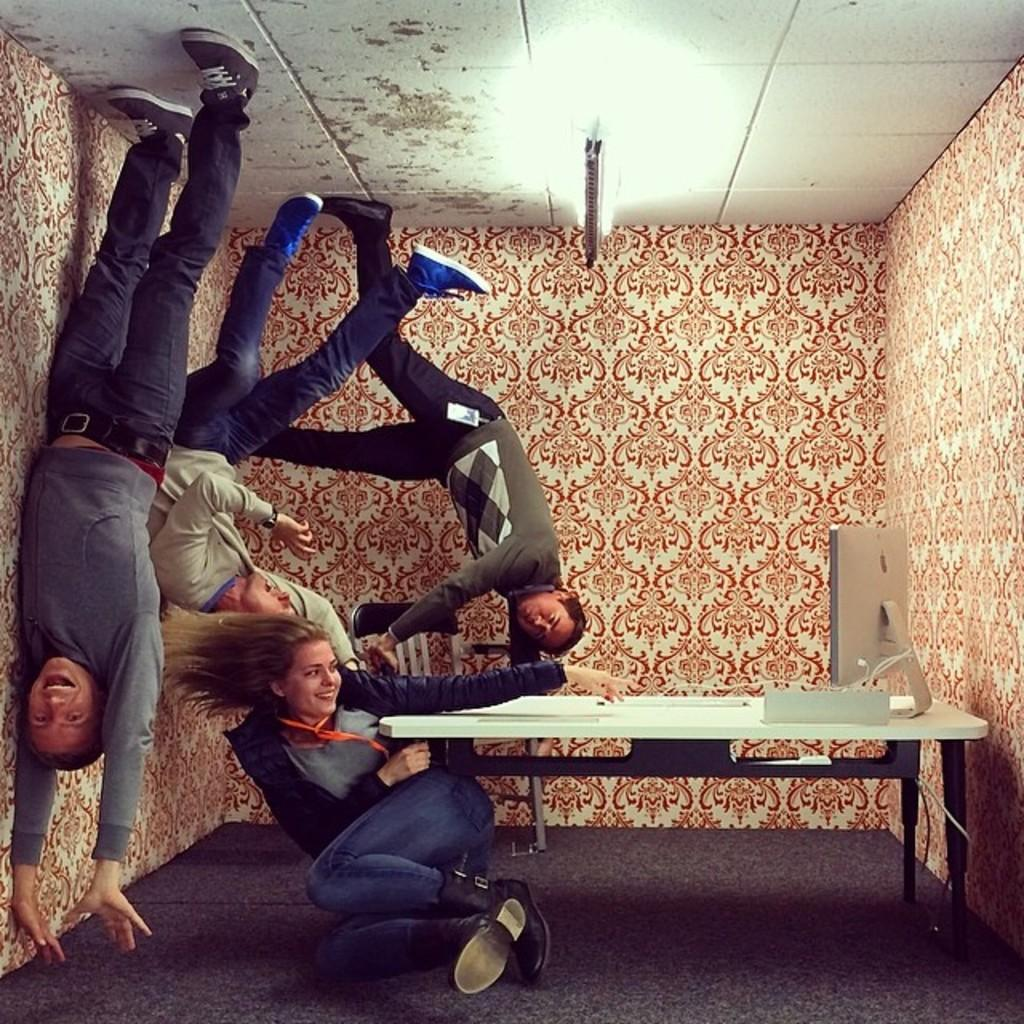How many people are in the image? There are four persons in the image. What is the main object in the image? There is a table in the image. What is on the table? A monitor is present on the table. What can be seen in the background of the image? There is a wall and a light visible in the image. What is the surface on which the table and people are standing? There is a floor in the image. What type of silk material is being used by the beginner in the image? There is no silk material or beginner present in the image. What type of suit is the person wearing in the image? There is no person wearing a suit in the image. 